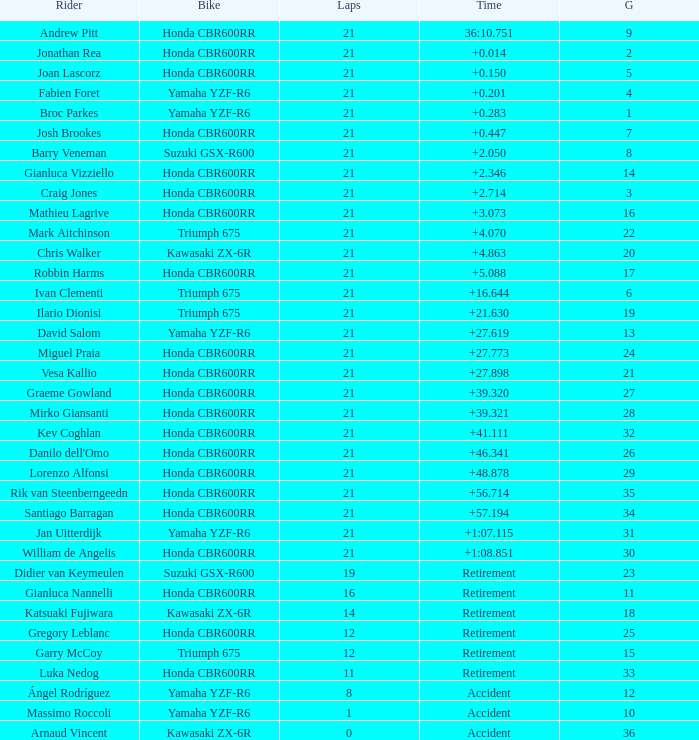What is the most number of laps run by Ilario Dionisi? 21.0. 